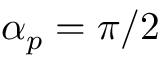<formula> <loc_0><loc_0><loc_500><loc_500>\alpha _ { p } = \pi / 2</formula> 